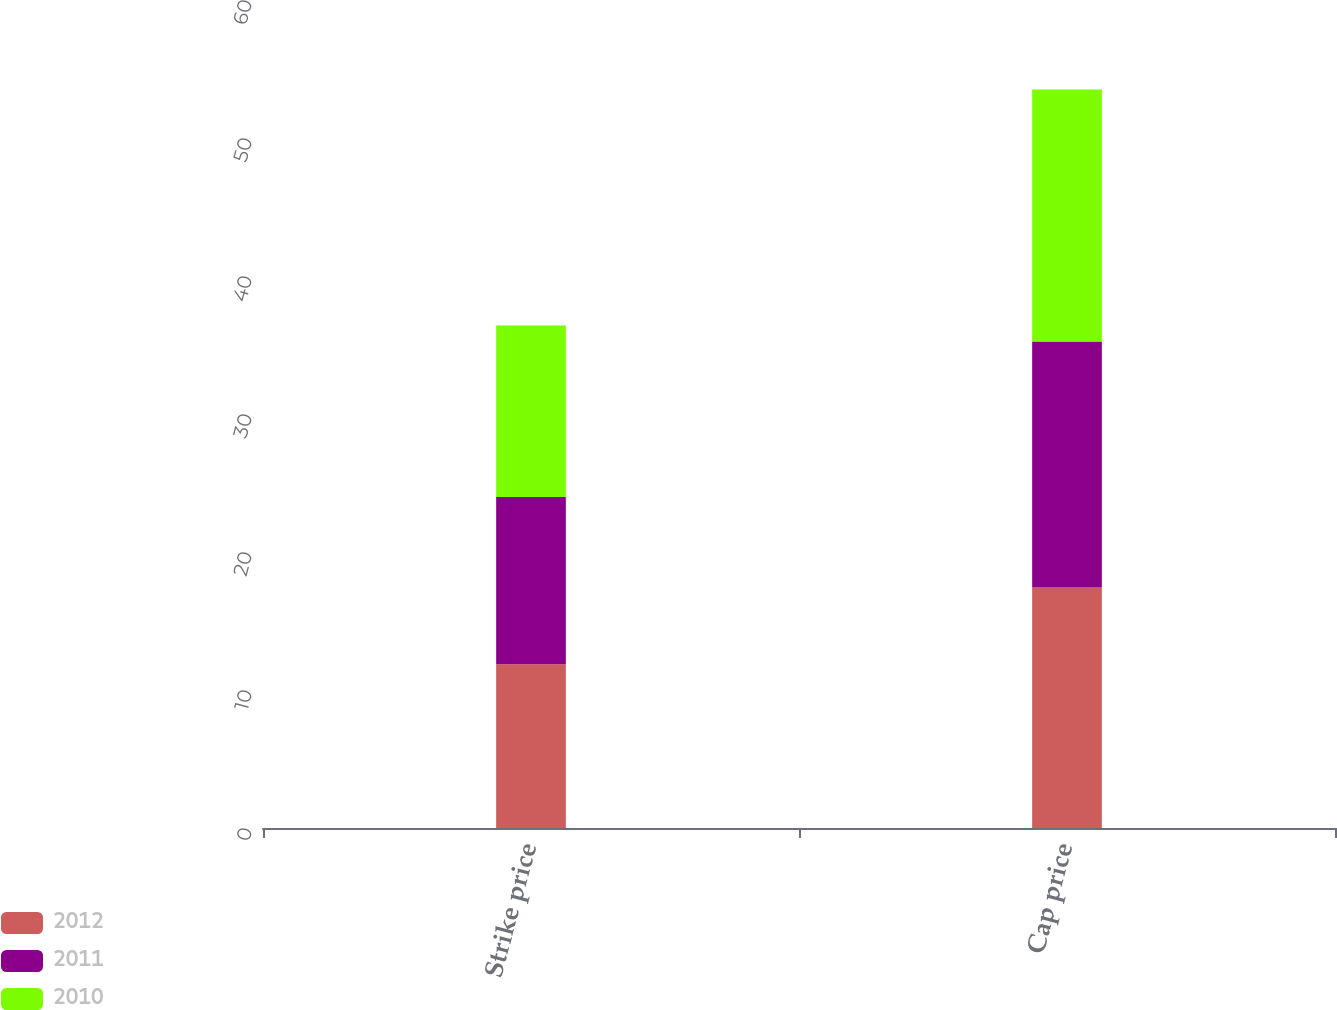Convert chart to OTSL. <chart><loc_0><loc_0><loc_500><loc_500><stacked_bar_chart><ecel><fcel>Strike price<fcel>Cap price<nl><fcel>2012<fcel>11.86<fcel>17.43<nl><fcel>2011<fcel>12.13<fcel>17.83<nl><fcel>2010<fcel>12.42<fcel>18.26<nl></chart> 